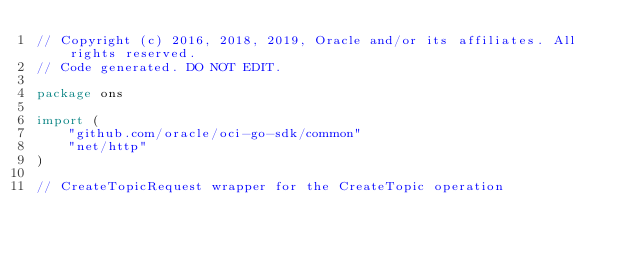<code> <loc_0><loc_0><loc_500><loc_500><_Go_>// Copyright (c) 2016, 2018, 2019, Oracle and/or its affiliates. All rights reserved.
// Code generated. DO NOT EDIT.

package ons

import (
	"github.com/oracle/oci-go-sdk/common"
	"net/http"
)

// CreateTopicRequest wrapper for the CreateTopic operation</code> 